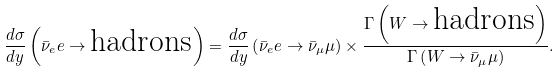<formula> <loc_0><loc_0><loc_500><loc_500>\frac { d \sigma } { d y } \left ( \bar { \nu } _ { e } e \to \text {hadrons} \right ) = \frac { d \sigma } { d y } \left ( \bar { \nu } _ { e } e \to \bar { \nu } _ { \mu } \mu \right ) \times \frac { \Gamma \left ( W \to \text {hadrons} \right ) } { \Gamma \left ( W \to \bar { \nu } _ { \mu } \mu \right ) } .</formula> 